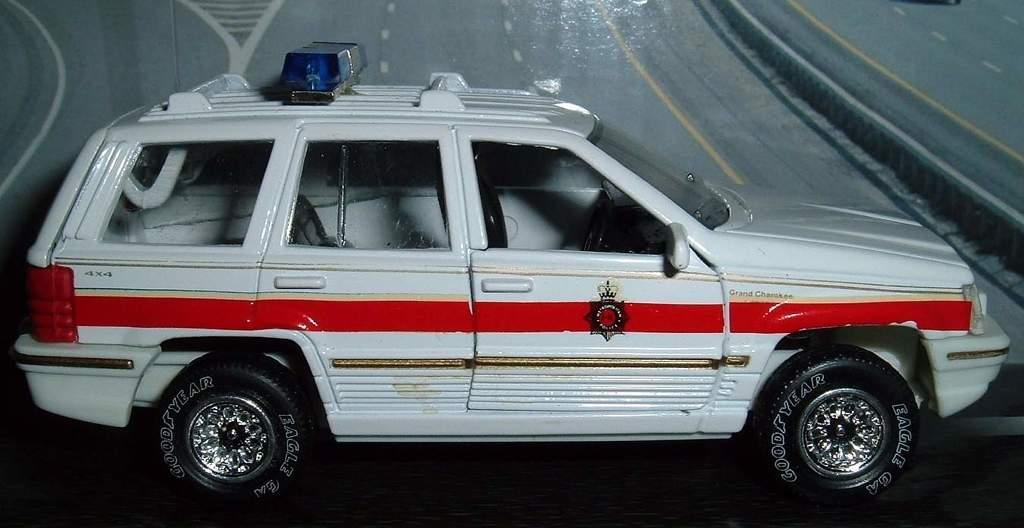What type of toy is present in the image? There is a toy car in the image. In which direction is the toy car facing? The toy car is facing towards the right side. What can be seen in the background of the image? There is a road visible in the background of the image. What type of train can be seen in the image? There is no train present in the image; it features a toy car facing towards the right side with a road visible in the background. 